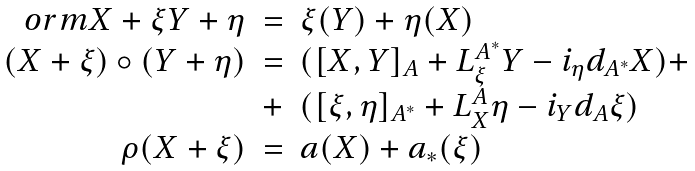Convert formula to latex. <formula><loc_0><loc_0><loc_500><loc_500>\begin{array} { r c l } o r m { X + \xi } { Y + \eta } & = & \xi ( Y ) + \eta ( X ) \\ ( X + \xi ) \circ ( Y + \eta ) & = & ( [ X , Y ] _ { A } + L _ { \xi } ^ { A ^ { * } } Y - i _ { \eta } d _ { A ^ { * } } X ) + \\ & + & ( [ \xi , \eta ] _ { A ^ { * } } + L ^ { A } _ { X } \eta - i _ { Y } d _ { A } \xi ) \\ \rho ( X + \xi ) & = & a ( X ) + a _ { * } ( \xi ) \end{array}</formula> 